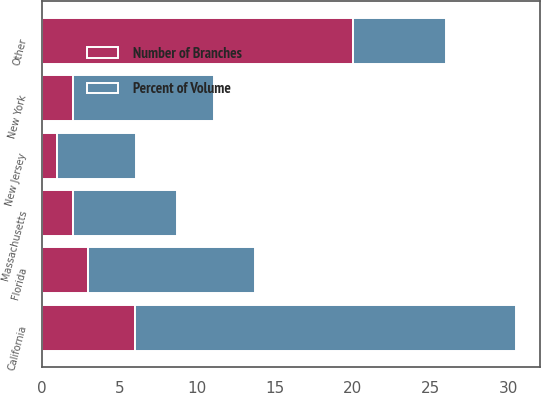Convert chart. <chart><loc_0><loc_0><loc_500><loc_500><stacked_bar_chart><ecel><fcel>California<fcel>Florida<fcel>New York<fcel>Massachusetts<fcel>New Jersey<fcel>Other<nl><fcel>Percent of Volume<fcel>24.5<fcel>10.7<fcel>9.1<fcel>6.7<fcel>5.1<fcel>6<nl><fcel>Number of Branches<fcel>6<fcel>3<fcel>2<fcel>2<fcel>1<fcel>20<nl></chart> 